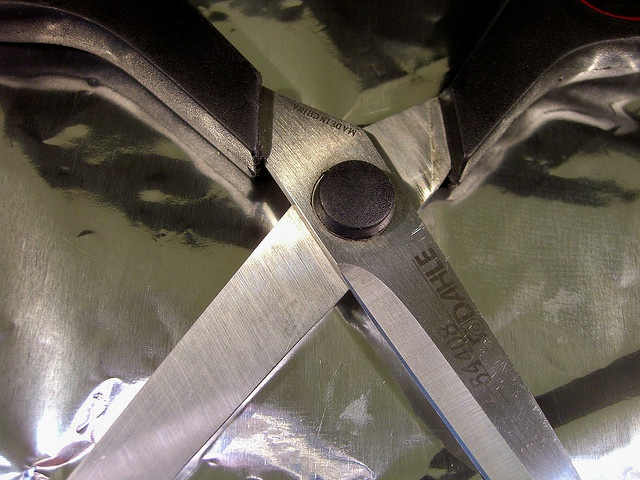Describe the objects in this image and their specific colors. I can see scissors in black, darkgray, and gray tones in this image. 